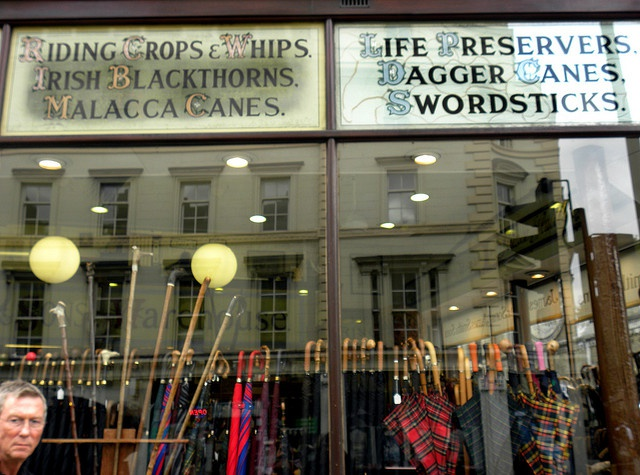Describe the objects in this image and their specific colors. I can see umbrella in black, gray, and tan tones, umbrella in black, maroon, and brown tones, people in black, salmon, brown, and lightgray tones, umbrella in black and gray tones, and umbrella in black, maroon, olive, and gray tones in this image. 